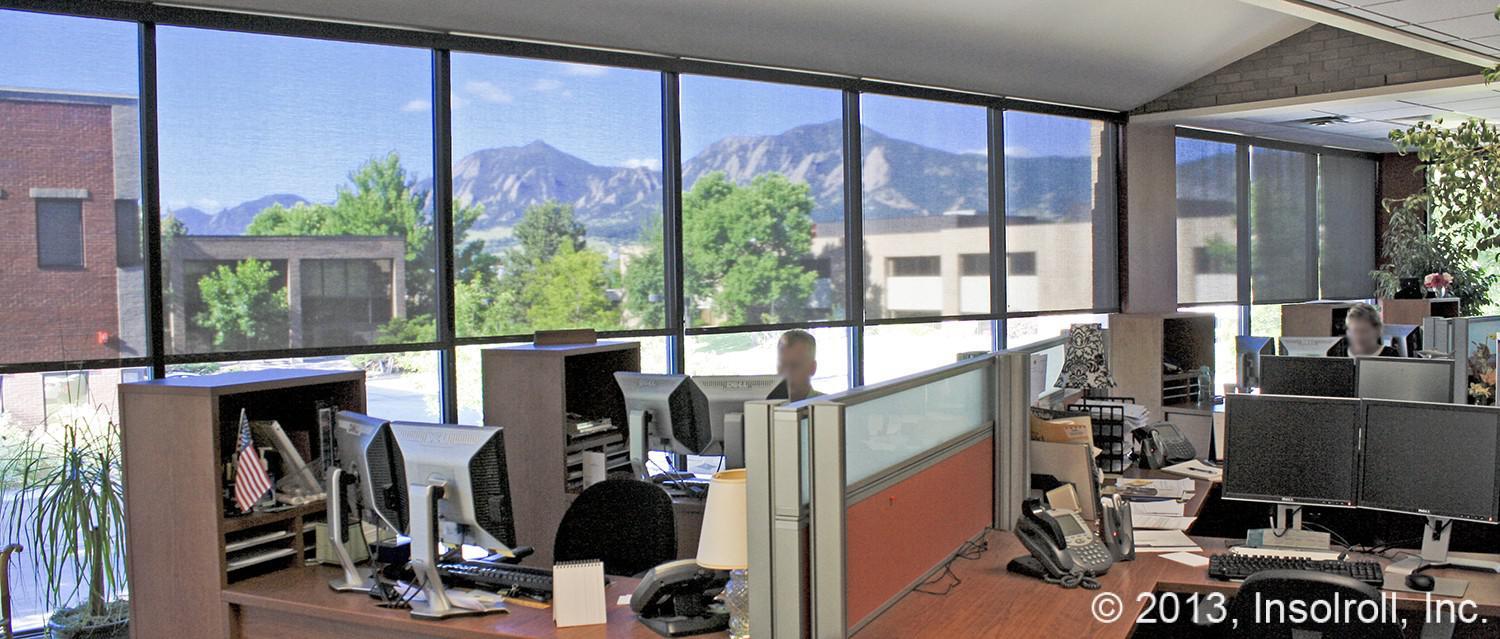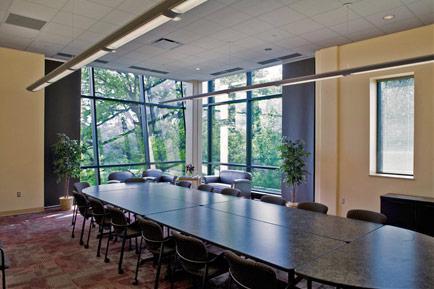The first image is the image on the left, the second image is the image on the right. Evaluate the accuracy of this statement regarding the images: "One image contains computers at desks, like in an office, and the other does not.". Is it true? Answer yes or no. Yes. The first image is the image on the left, the second image is the image on the right. Considering the images on both sides, is "An image shows an office space with a wall of square-paned window in front of work-stations." valid? Answer yes or no. Yes. 